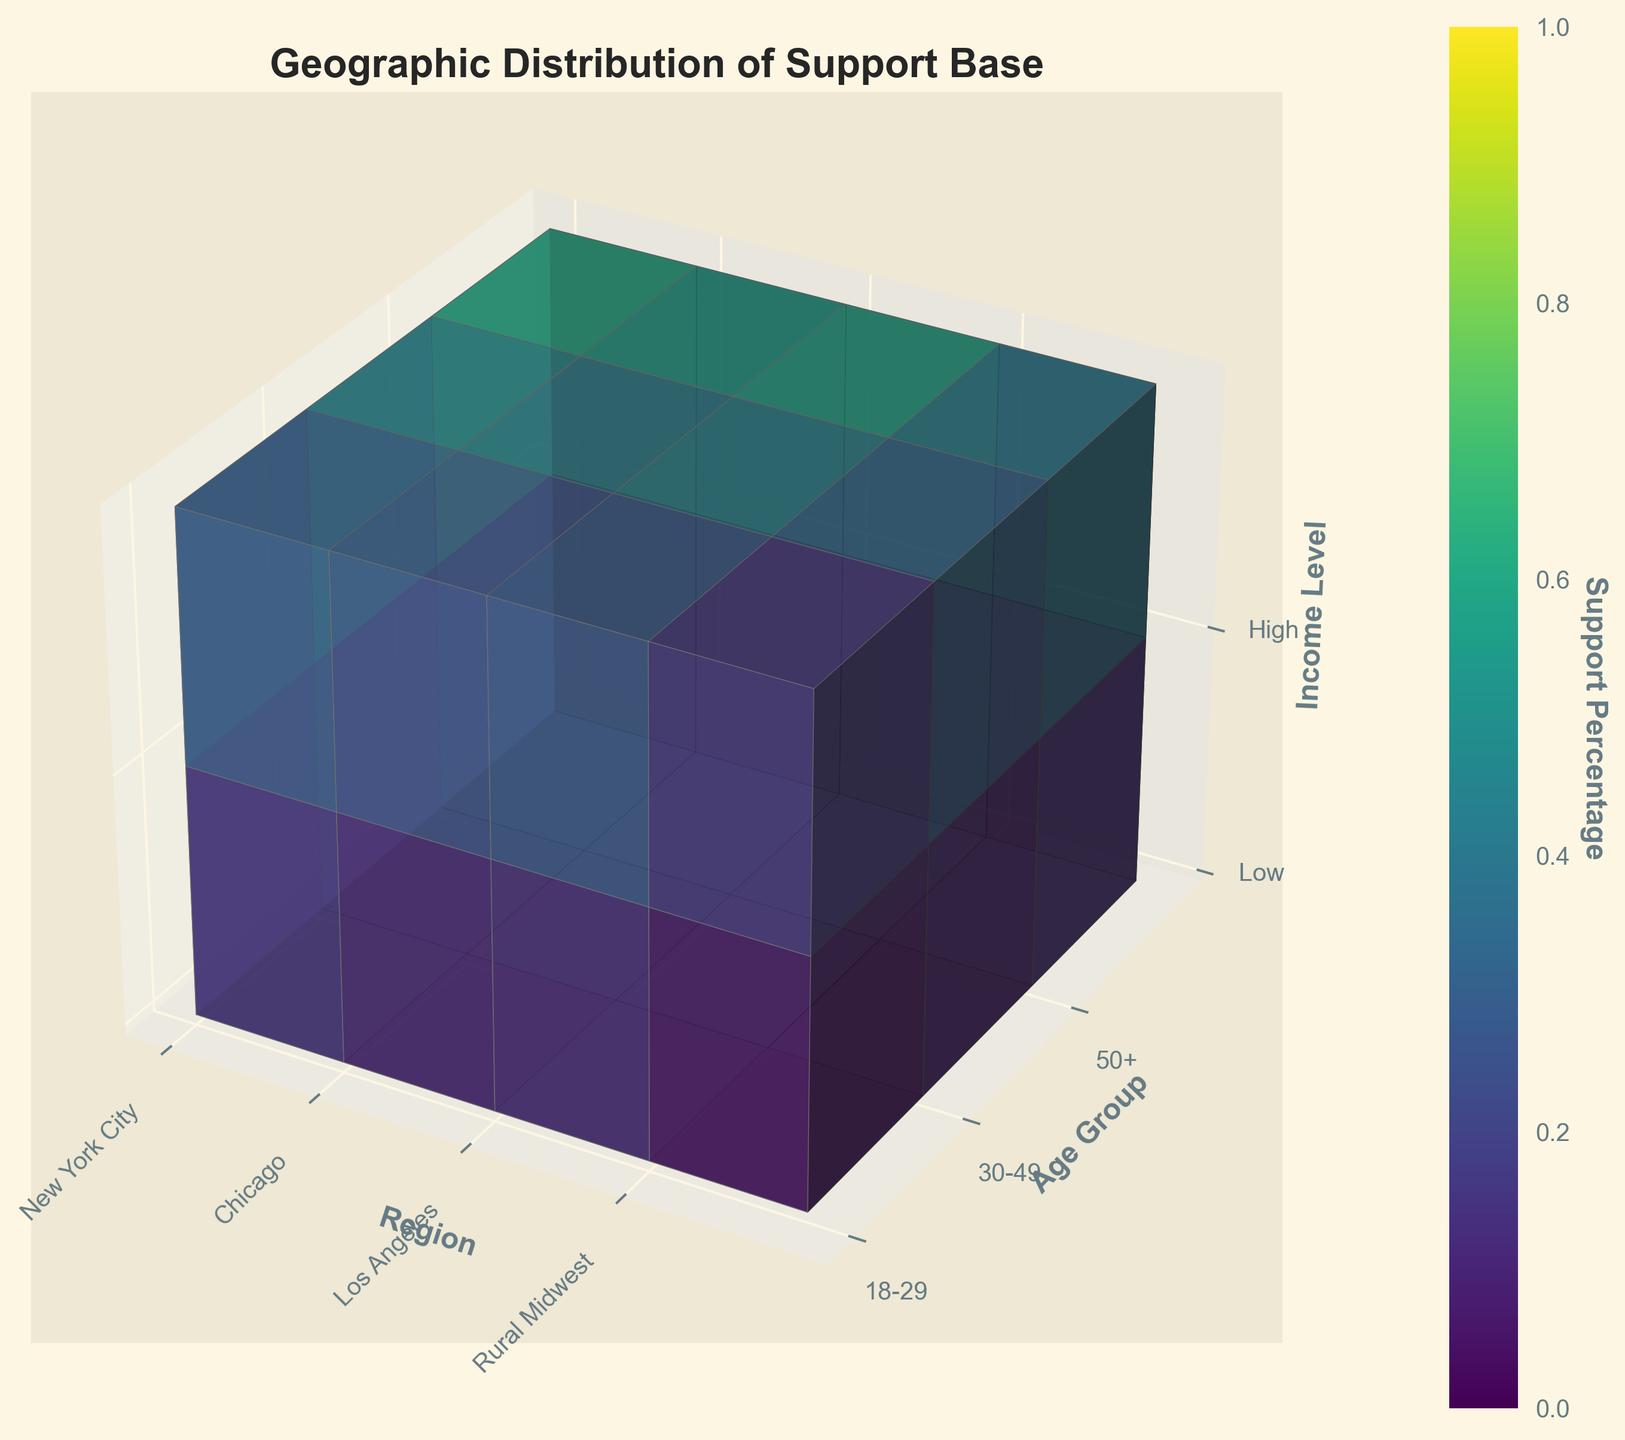What is the title of the figure? It's written at the top of the figure as "Geographic Distribution of Support Base".
Answer: Geographic Distribution of Support Base Which region has the highest support percentage for the 50+ age group with high income? By examining the 3D color pattern, New York City has the darkest color indicating the highest percentage for the 50+ age group with high income.
Answer: New York City How does the support percentage for low-income 18-29 year olds in Rural Midwest compare to Chicago? By analyzing the corresponding voxel colors, the support percentage in Rural Midwest is lower than in Chicago for low-income 18-29 year olds.
Answer: Lower What is the average support percentage for high-income individuals in the 30-49 age group across all regions? Calculate the average of support percentages: (45 + 40 + 42 + 30) / 4 which is (157 / 4) = 39.25
Answer: 39.25 Which age group has the most support in Los Angeles? Comparing colors within the Los Angeles section, the darkest color is for the 50+ age group indicating the highest support.
Answer: 50+ What is the range of support percentages for low-income individuals in New York City across all age groups? Identify the lowest and highest percentages: 15 (18-29) and 25 (50+), then find the range: 25 - 15 = 10
Answer: 10 Which region has the lowest support percentage for 30-49 year olds with low-income? The least dark voxel in the 30-49 and low-income sections corresponds to Rural Midwest.
Answer: Rural Midwest Compare the support percentages of high-income for 18-29 vs. 50+ age group in Chicago. The voxels show 25% for 18-29 and 55% for 50+, thus 50+ has a higher support percentage.
Answer: 50+ is higher Identify the age group and income level with the highest support percentage in the data. The darkest color voxel indicates the highest support, which corresponds to 50+ age group and high-income level in New York City.
Answer: 50+, High income 